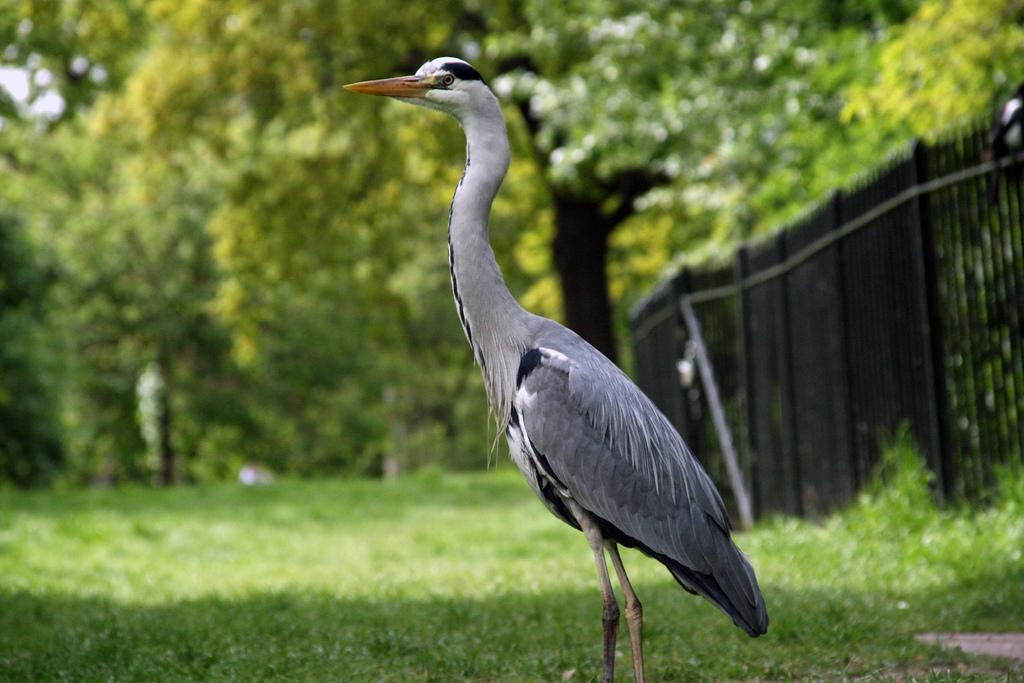What type of vegetation can be seen in the image? There are trees and grass in the image. What structure is located in the middle of the image? There is a crane in the middle of the image. What type of barrier is present on the right side of the image? There is a fence on the right side of the image. What type of floor can be seen in the image? There is no floor visible in the image; it features trees, grass, a crane, and a fence. What type of coach is present in the image? There is no coach present in the image. 